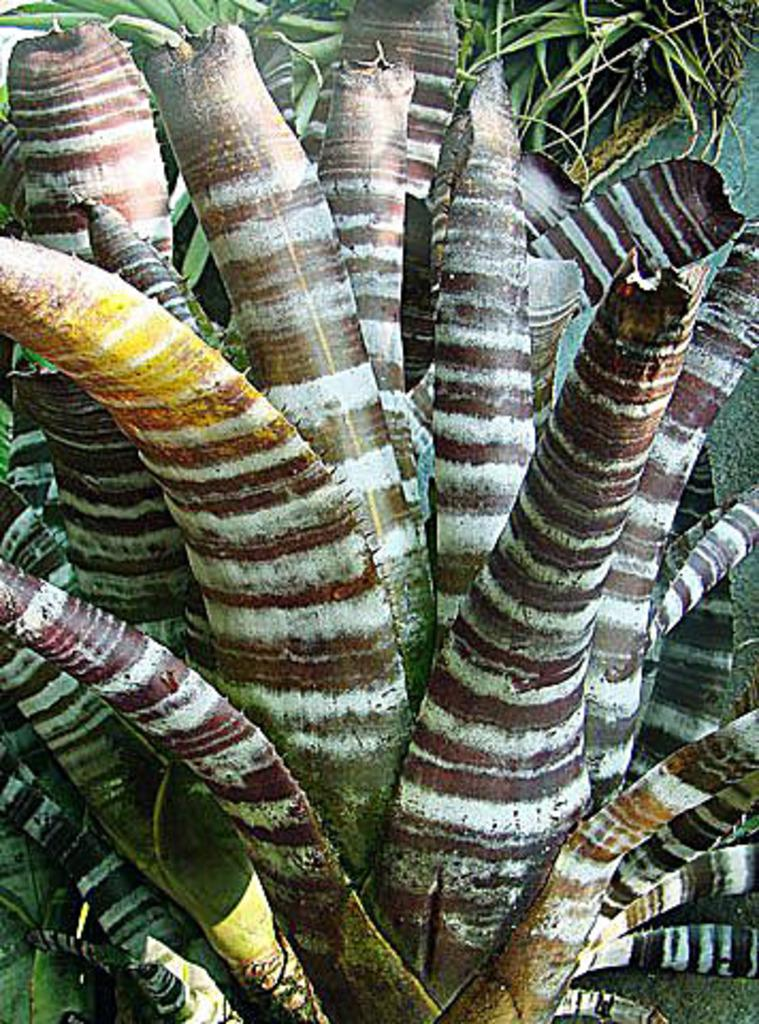What is the main subject in the middle of the image? There is a plant in the middle of the image. Can you describe the surrounding area in the image? There are other plants in the background of the image. What type of toothbrush is hanging on the plant in the image? There is no toothbrush present in the image; it features plants only. 